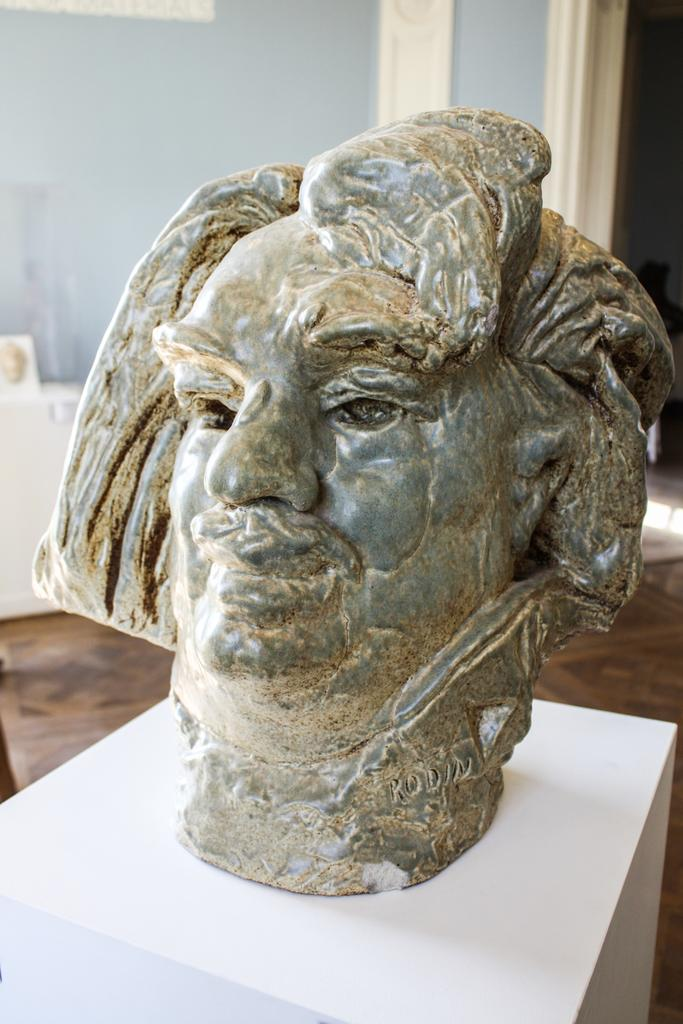What is the main subject of the image? The main subject of the image is a sculpture on a box. Can you describe the background of the image? There is a wall in the background of the image. What type of kettle is hanging from the sculpture in the image? There is no kettle present in the image; it features a sculpture on a box and a wall in the background. How many strands of hair can be seen on the sculpture in the image? There is no hair present on the sculpture in the image. 